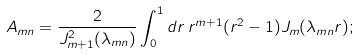Convert formula to latex. <formula><loc_0><loc_0><loc_500><loc_500>A _ { m n } = \frac { 2 } { J _ { m + 1 } ^ { 2 } ( \lambda _ { m n } ) } \int _ { 0 } ^ { 1 } d r \, r ^ { m + 1 } ( r ^ { 2 } - 1 ) J _ { m } ( \lambda _ { m n } r ) ;</formula> 